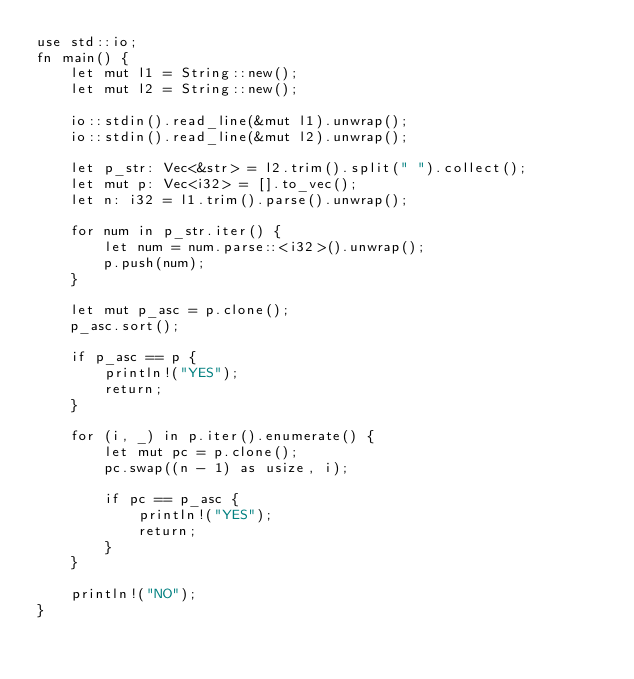Convert code to text. <code><loc_0><loc_0><loc_500><loc_500><_Rust_>use std::io;
fn main() {
    let mut l1 = String::new();
    let mut l2 = String::new();

    io::stdin().read_line(&mut l1).unwrap();
    io::stdin().read_line(&mut l2).unwrap();

    let p_str: Vec<&str> = l2.trim().split(" ").collect();
    let mut p: Vec<i32> = [].to_vec();
    let n: i32 = l1.trim().parse().unwrap();

    for num in p_str.iter() {
        let num = num.parse::<i32>().unwrap();
        p.push(num);
    }

    let mut p_asc = p.clone();
    p_asc.sort();

    if p_asc == p {
        println!("YES");
        return;
    }

    for (i, _) in p.iter().enumerate() {
        let mut pc = p.clone();
        pc.swap((n - 1) as usize, i);

        if pc == p_asc {
            println!("YES");
            return;
        }
    }

    println!("NO");
}
</code> 